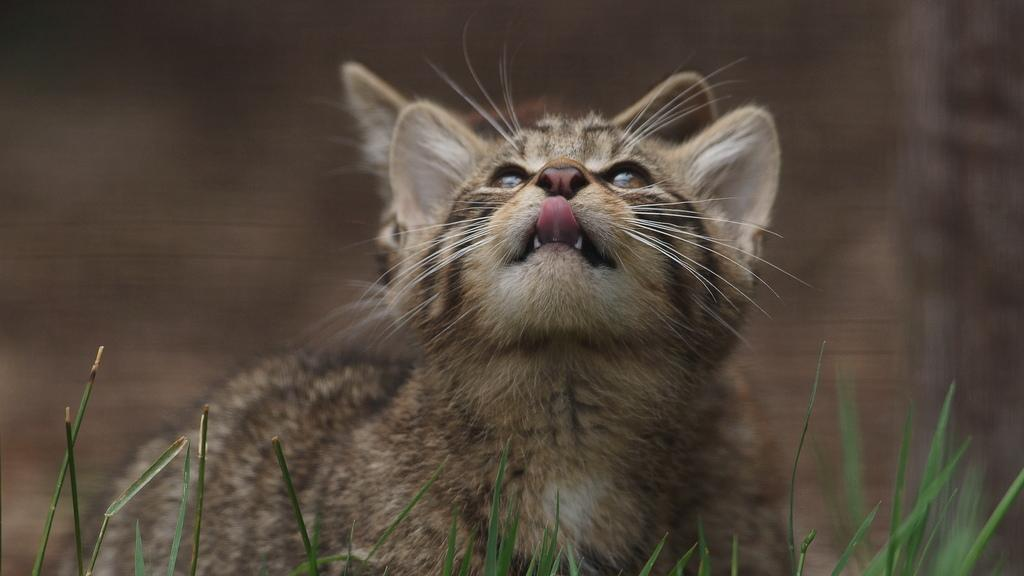What type of animal is in the image? There is a cat in the image. How would you describe the background of the image? The background of the image is blurred. What type of vegetation is visible at the bottom of the image? There is grass at the bottom of the image. What flavor of river can be seen in the image? There is no river present in the image, so it is not possible to determine its flavor. 